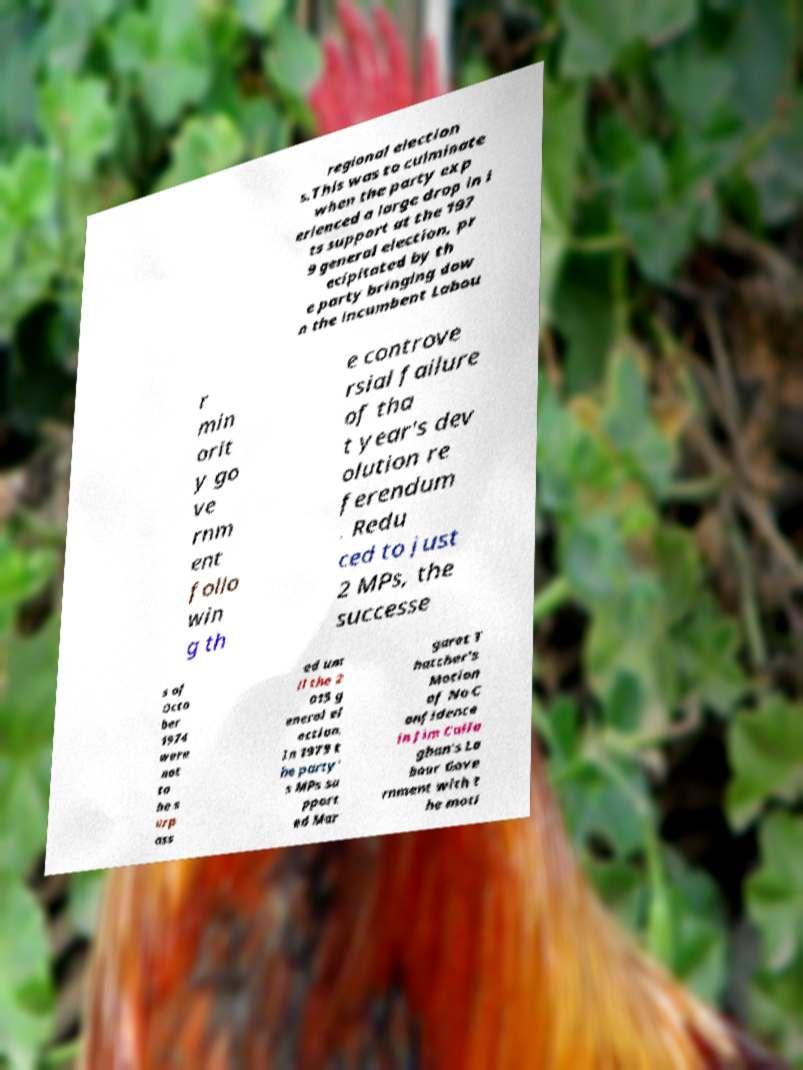Please read and relay the text visible in this image. What does it say? regional election s.This was to culminate when the party exp erienced a large drop in i ts support at the 197 9 general election, pr ecipitated by th e party bringing dow n the incumbent Labou r min orit y go ve rnm ent follo win g th e controve rsial failure of tha t year's dev olution re ferendum . Redu ced to just 2 MPs, the successe s of Octo ber 1974 were not to be s urp ass ed unt il the 2 015 g eneral el ection. In 1979 t he party' s MPs su pport ed Mar garet T hatcher's Motion of No C onfidence in Jim Calla ghan's La bour Gove rnment with t he moti 